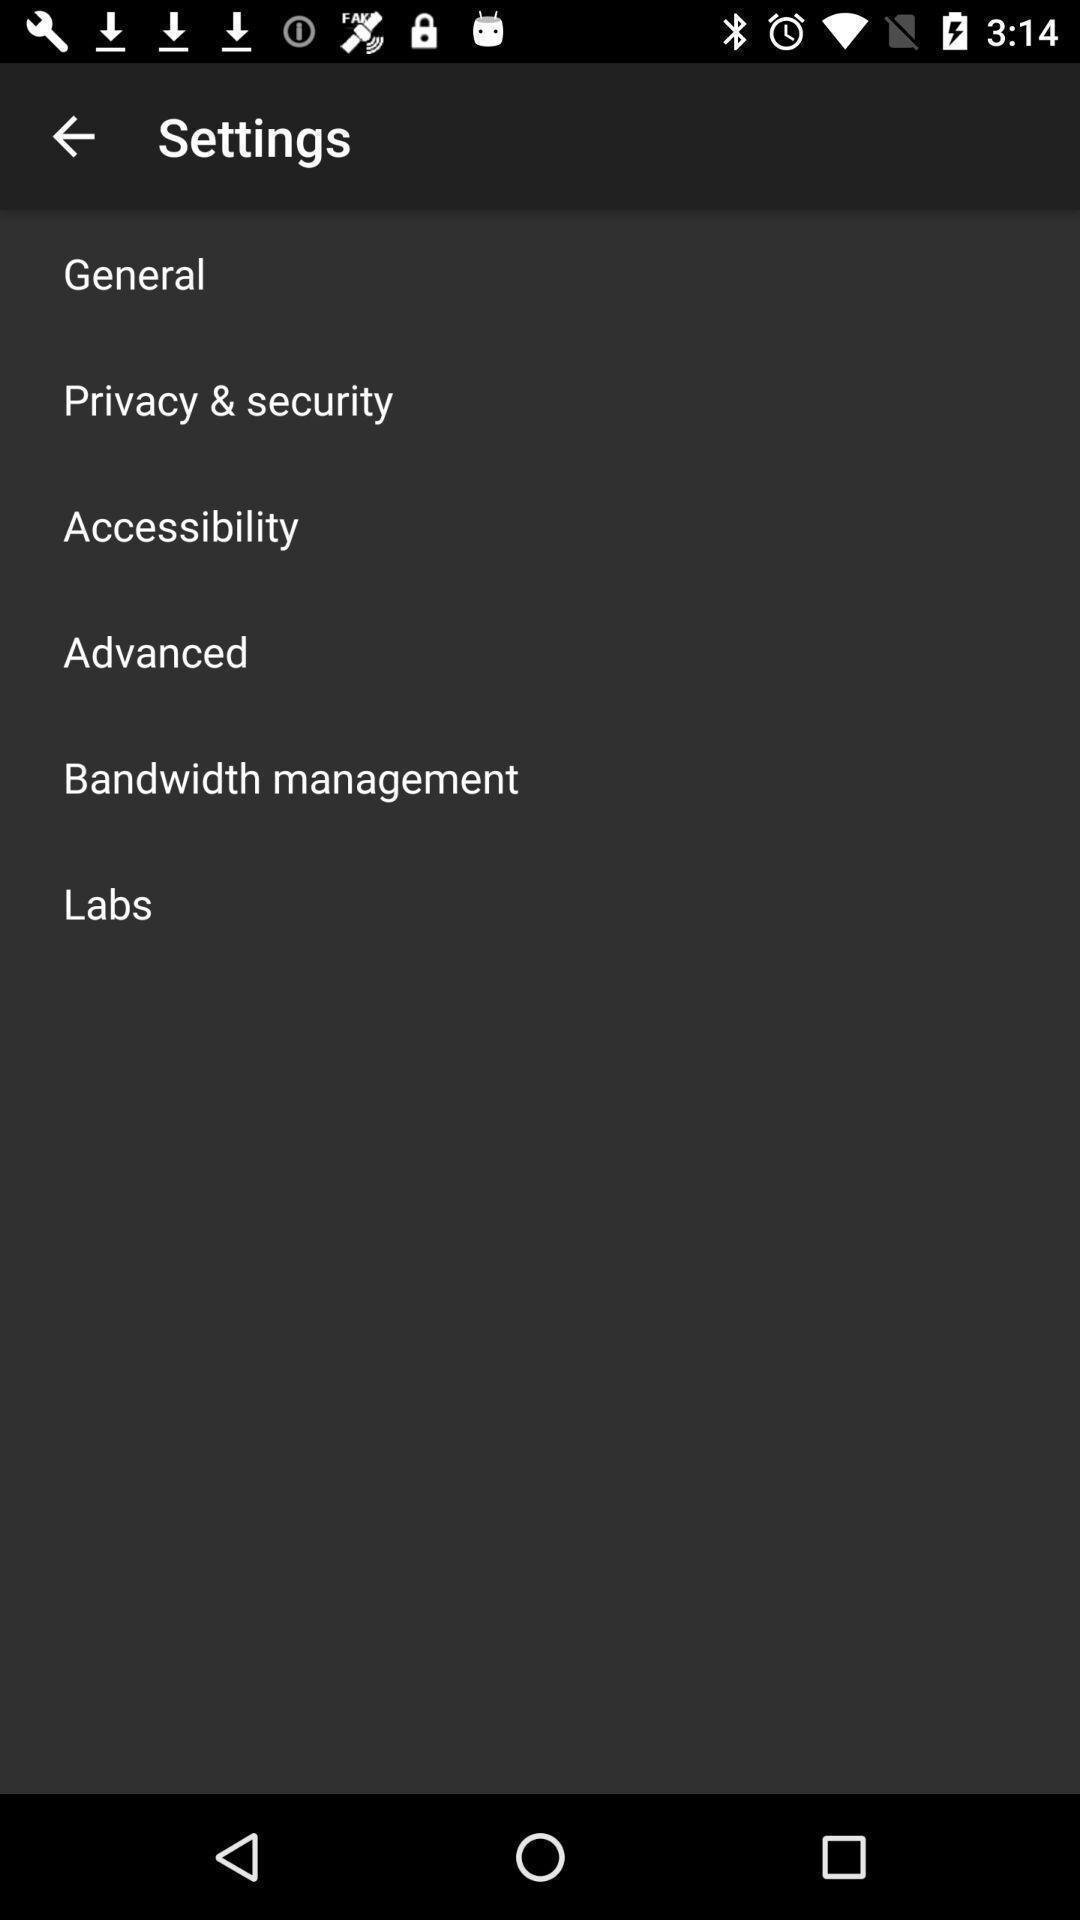Provide a detailed account of this screenshot. Settings page displayed. 